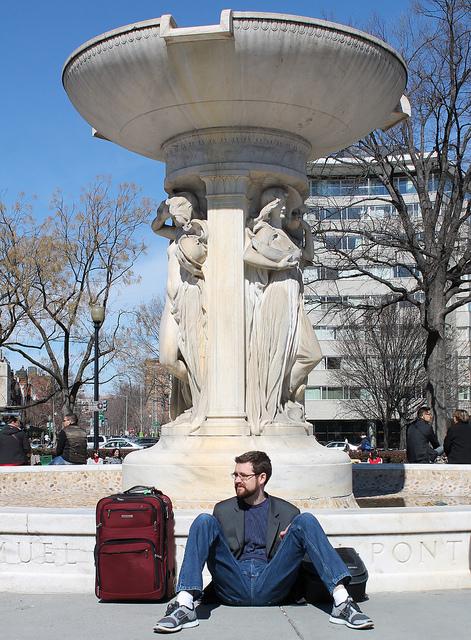Is the man sitting?
Concise answer only. Yes. What color is his case?
Answer briefly. Red. Is there sculpture on the fountain behind him?
Answer briefly. Yes. 